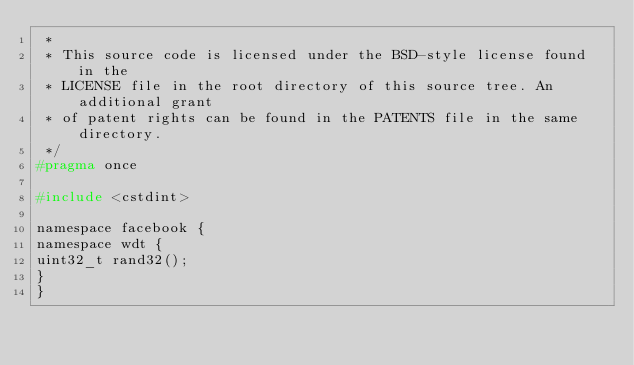Convert code to text. <code><loc_0><loc_0><loc_500><loc_500><_C_> *
 * This source code is licensed under the BSD-style license found in the
 * LICENSE file in the root directory of this source tree. An additional grant
 * of patent rights can be found in the PATENTS file in the same directory.
 */
#pragma once

#include <cstdint>

namespace facebook {
namespace wdt {
uint32_t rand32();
}
}
</code> 